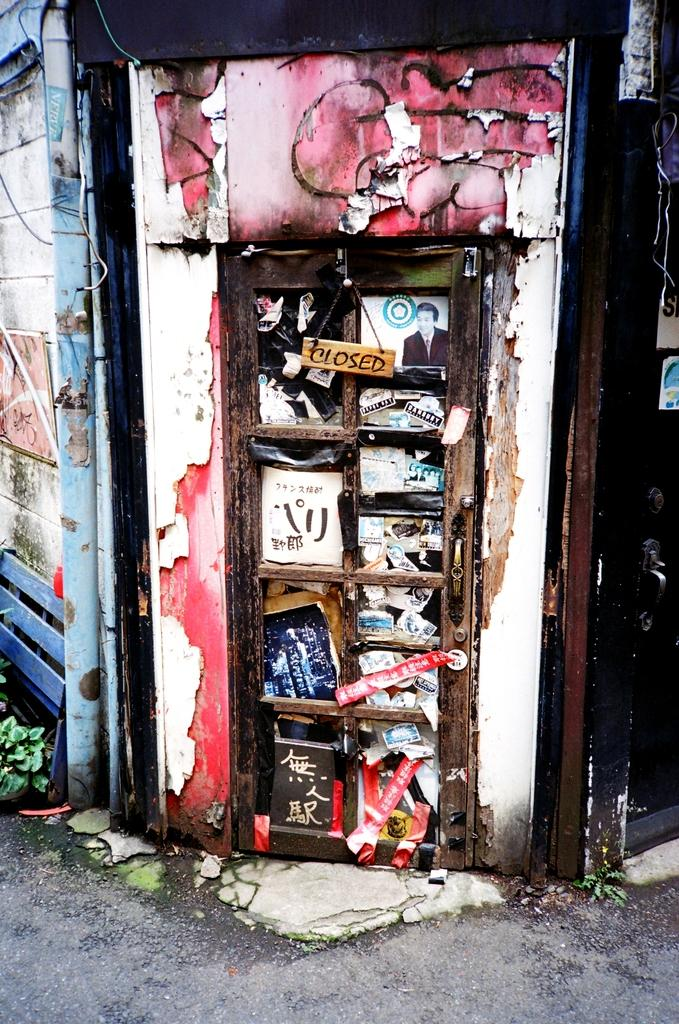What is the main object in the image? There is a board in the image. What can be seen on the door in the image? There are papers on the door in the image. What is attached to the wall in the image? There is a pipe on the wall in the image. How many goldfish are swimming in the bowl on the board in the image? There is no bowl or goldfish present in the image. 